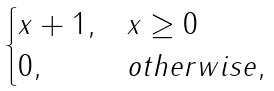Convert formula to latex. <formula><loc_0><loc_0><loc_500><loc_500>\begin{cases} x + 1 , & x \geq 0 \\ 0 , & o t h e r w i s e , \end{cases}</formula> 